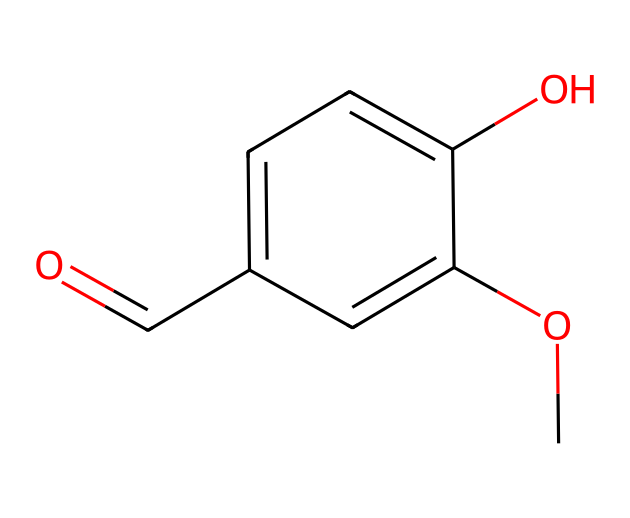What is the molecular formula of vanillin? The molecular formula can be derived from the SMILES notation by counting the types and numbers of atoms present. The notation contains one carbonyl (C=O) group and a methoxy (OCH3) group, along with the aromatic ring containing six carbon atoms. Counting all atoms gives C8H8O3.
Answer: C8H8O3 How many hydroxyl groups are present in vanillin? Looking at the SMILES structure, we can identify the -OH group, which indicates a hydroxyl. There is one such -OH group directly attached to the aromatic ring structure.
Answer: 1 What type of functional group is present at the end of the molecule? The function at the end of the molecule is a carbonyl group (C=O), a characteristic of aldehydes. The presence of the carbonyl bonded to a hydrogen atom indicates it's an aldehyde functional group.
Answer: aldehyde What is the role of the methoxy group in vanillin's structure? The methoxy group (-OCH3) contributes to the aromatic characteristics of the compound, enhancing its solubility in organic solvents, and modulating the aromatic flavor profile by influencing electronic properties.
Answer: enhances aroma What type of chemical compound is vanillin classified as? Vanillin is classified as an aromatic compound due to the presence of the benzene-like ring structure (circular arrangement of carbon atoms with delocalized pi electrons), which qualifies it under this class.
Answer: aromatic compound How many carbon atoms are part of the aromatic ring in vanillin? The aromatic ring in vanillin consists of six carbon atoms as indicated in the structure. This is typical for compounds possessing a benzene ring. Counting these specific carbon atoms leads to the total of six in the ring.
Answer: 6 